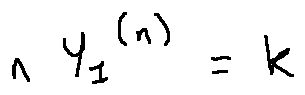Convert formula to latex. <formula><loc_0><loc_0><loc_500><loc_500>n Y _ { 1 } ^ { ( n ) } = k</formula> 